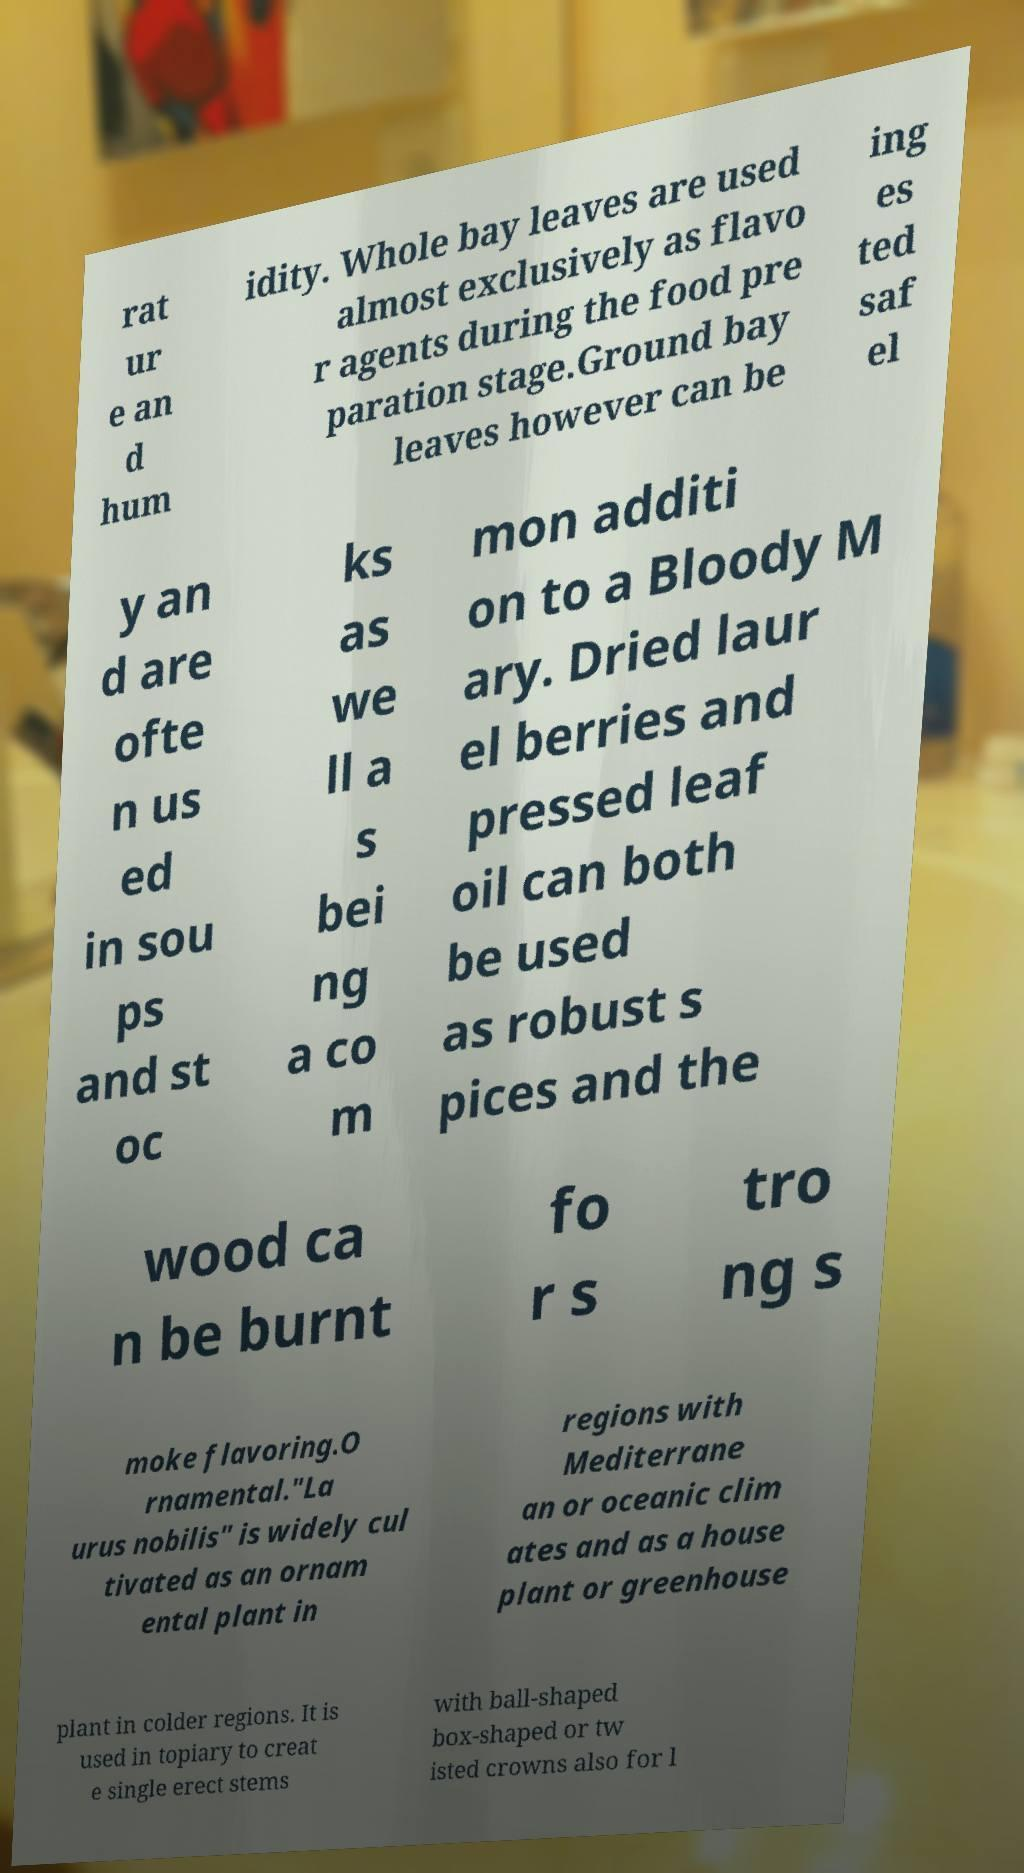Could you assist in decoding the text presented in this image and type it out clearly? rat ur e an d hum idity. Whole bay leaves are used almost exclusively as flavo r agents during the food pre paration stage.Ground bay leaves however can be ing es ted saf el y an d are ofte n us ed in sou ps and st oc ks as we ll a s bei ng a co m mon additi on to a Bloody M ary. Dried laur el berries and pressed leaf oil can both be used as robust s pices and the wood ca n be burnt fo r s tro ng s moke flavoring.O rnamental."La urus nobilis" is widely cul tivated as an ornam ental plant in regions with Mediterrane an or oceanic clim ates and as a house plant or greenhouse plant in colder regions. It is used in topiary to creat e single erect stems with ball-shaped box-shaped or tw isted crowns also for l 